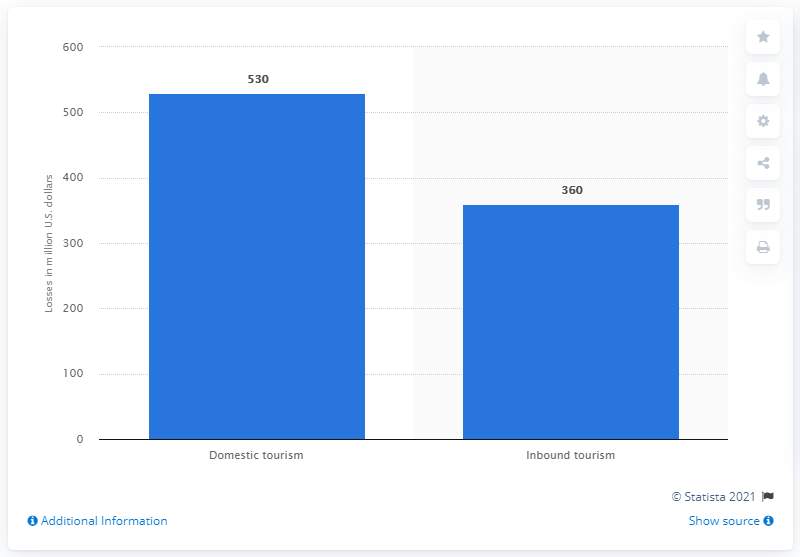Indicate a few pertinent items in this graphic. Inbound tourism was projected to lose approximately $360 million in Bolivia in 2020, according to forecasts. The Bolivian tourism sector is projected to lose an estimated $530 million in domestic travel in 2020 due to the COVID-19 pandemic. 